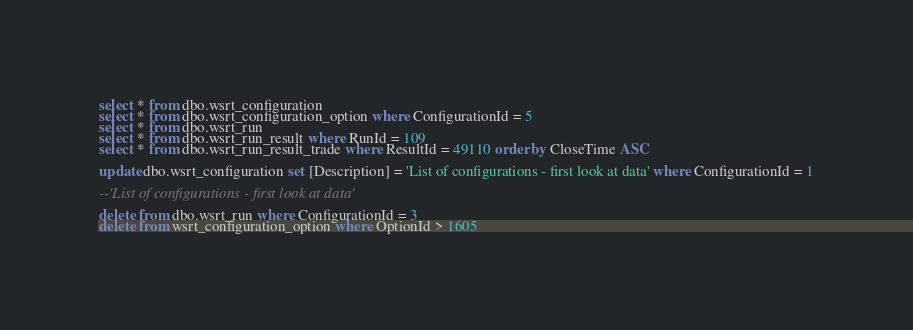<code> <loc_0><loc_0><loc_500><loc_500><_SQL_>
select * from dbo.wsrt_configuration
select * from dbo.wsrt_configuration_option where ConfigurationId = 5
select * from dbo.wsrt_run
select * from dbo.wsrt_run_result where RunId = 109
select * from dbo.wsrt_run_result_trade where ResultId = 49110 order by CloseTime ASC

update dbo.wsrt_configuration set [Description] = 'List of configurations - first look at data' where ConfigurationId = 1

--'List of configurations - first look at data'

delete from dbo.wsrt_run where ConfigurationId = 3
delete from wsrt_configuration_option where OptionId > 1605</code> 